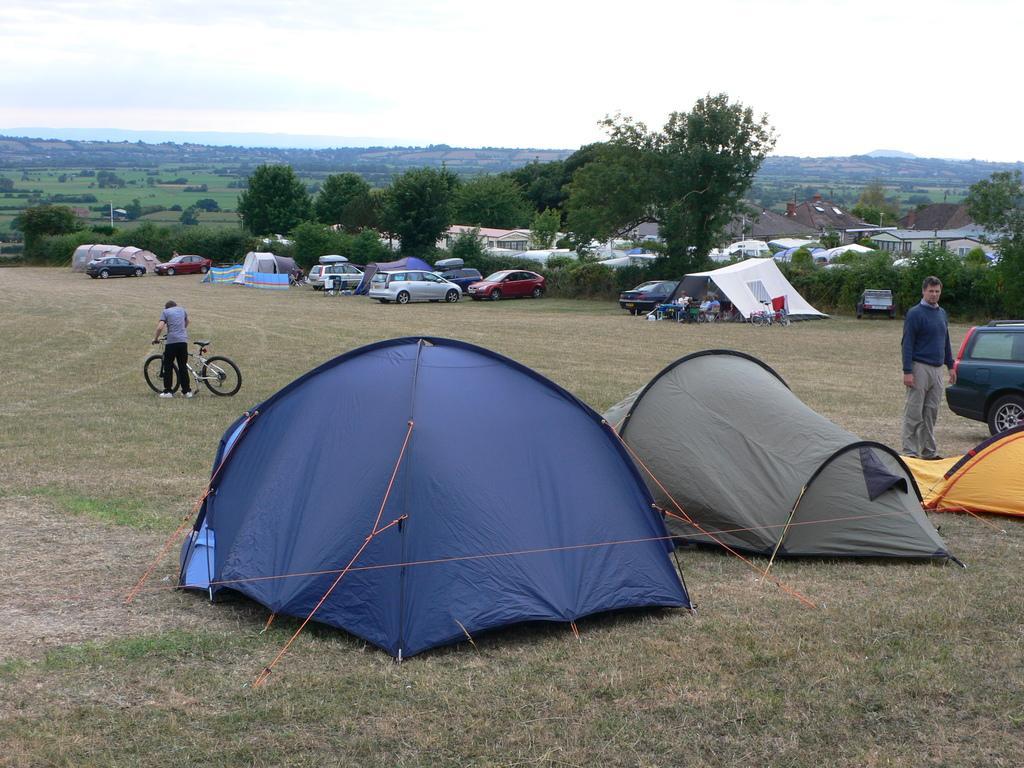Describe this image in one or two sentences. Here we can see tents. Background there are vehicles, trees, plants and sky. Sky is cloudy. Beside this car a person is standing. Another person is holding a bicycle. Far there are houses.  